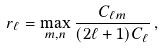Convert formula to latex. <formula><loc_0><loc_0><loc_500><loc_500>r _ { \ell } = \max _ { m , { n } } \frac { C _ { \ell m } } { ( 2 \ell + 1 ) C _ { \ell } } \, ,</formula> 